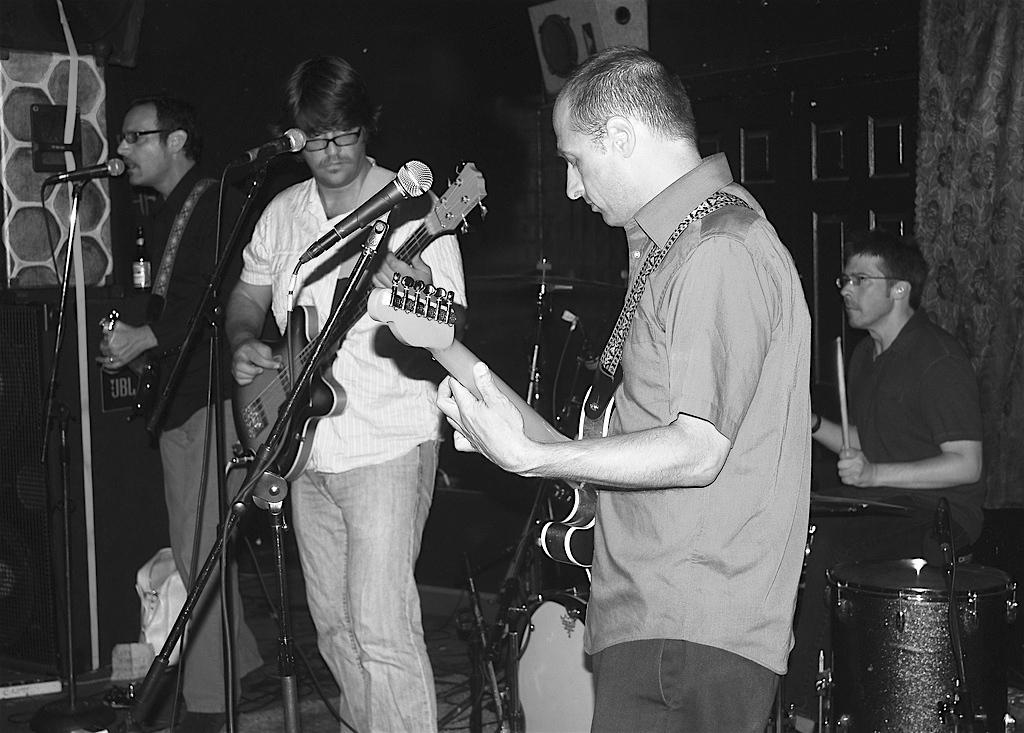Describe this image in one or two sentences. In the image we can see three persons were standing and holding guitar. And in front there is a microphone. In the background we can see wall,speaker and few musical instruments and one person holding stick. 